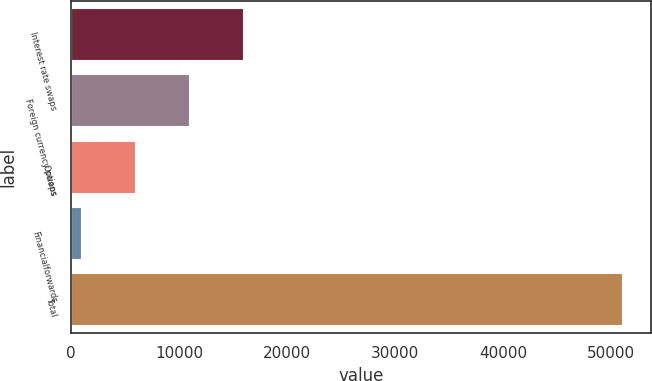Convert chart. <chart><loc_0><loc_0><loc_500><loc_500><bar_chart><fcel>Interest rate swaps<fcel>Foreign currency swaps<fcel>Options<fcel>Financialforwards<fcel>Total<nl><fcel>16030.4<fcel>11018.6<fcel>6006.8<fcel>995<fcel>51113<nl></chart> 